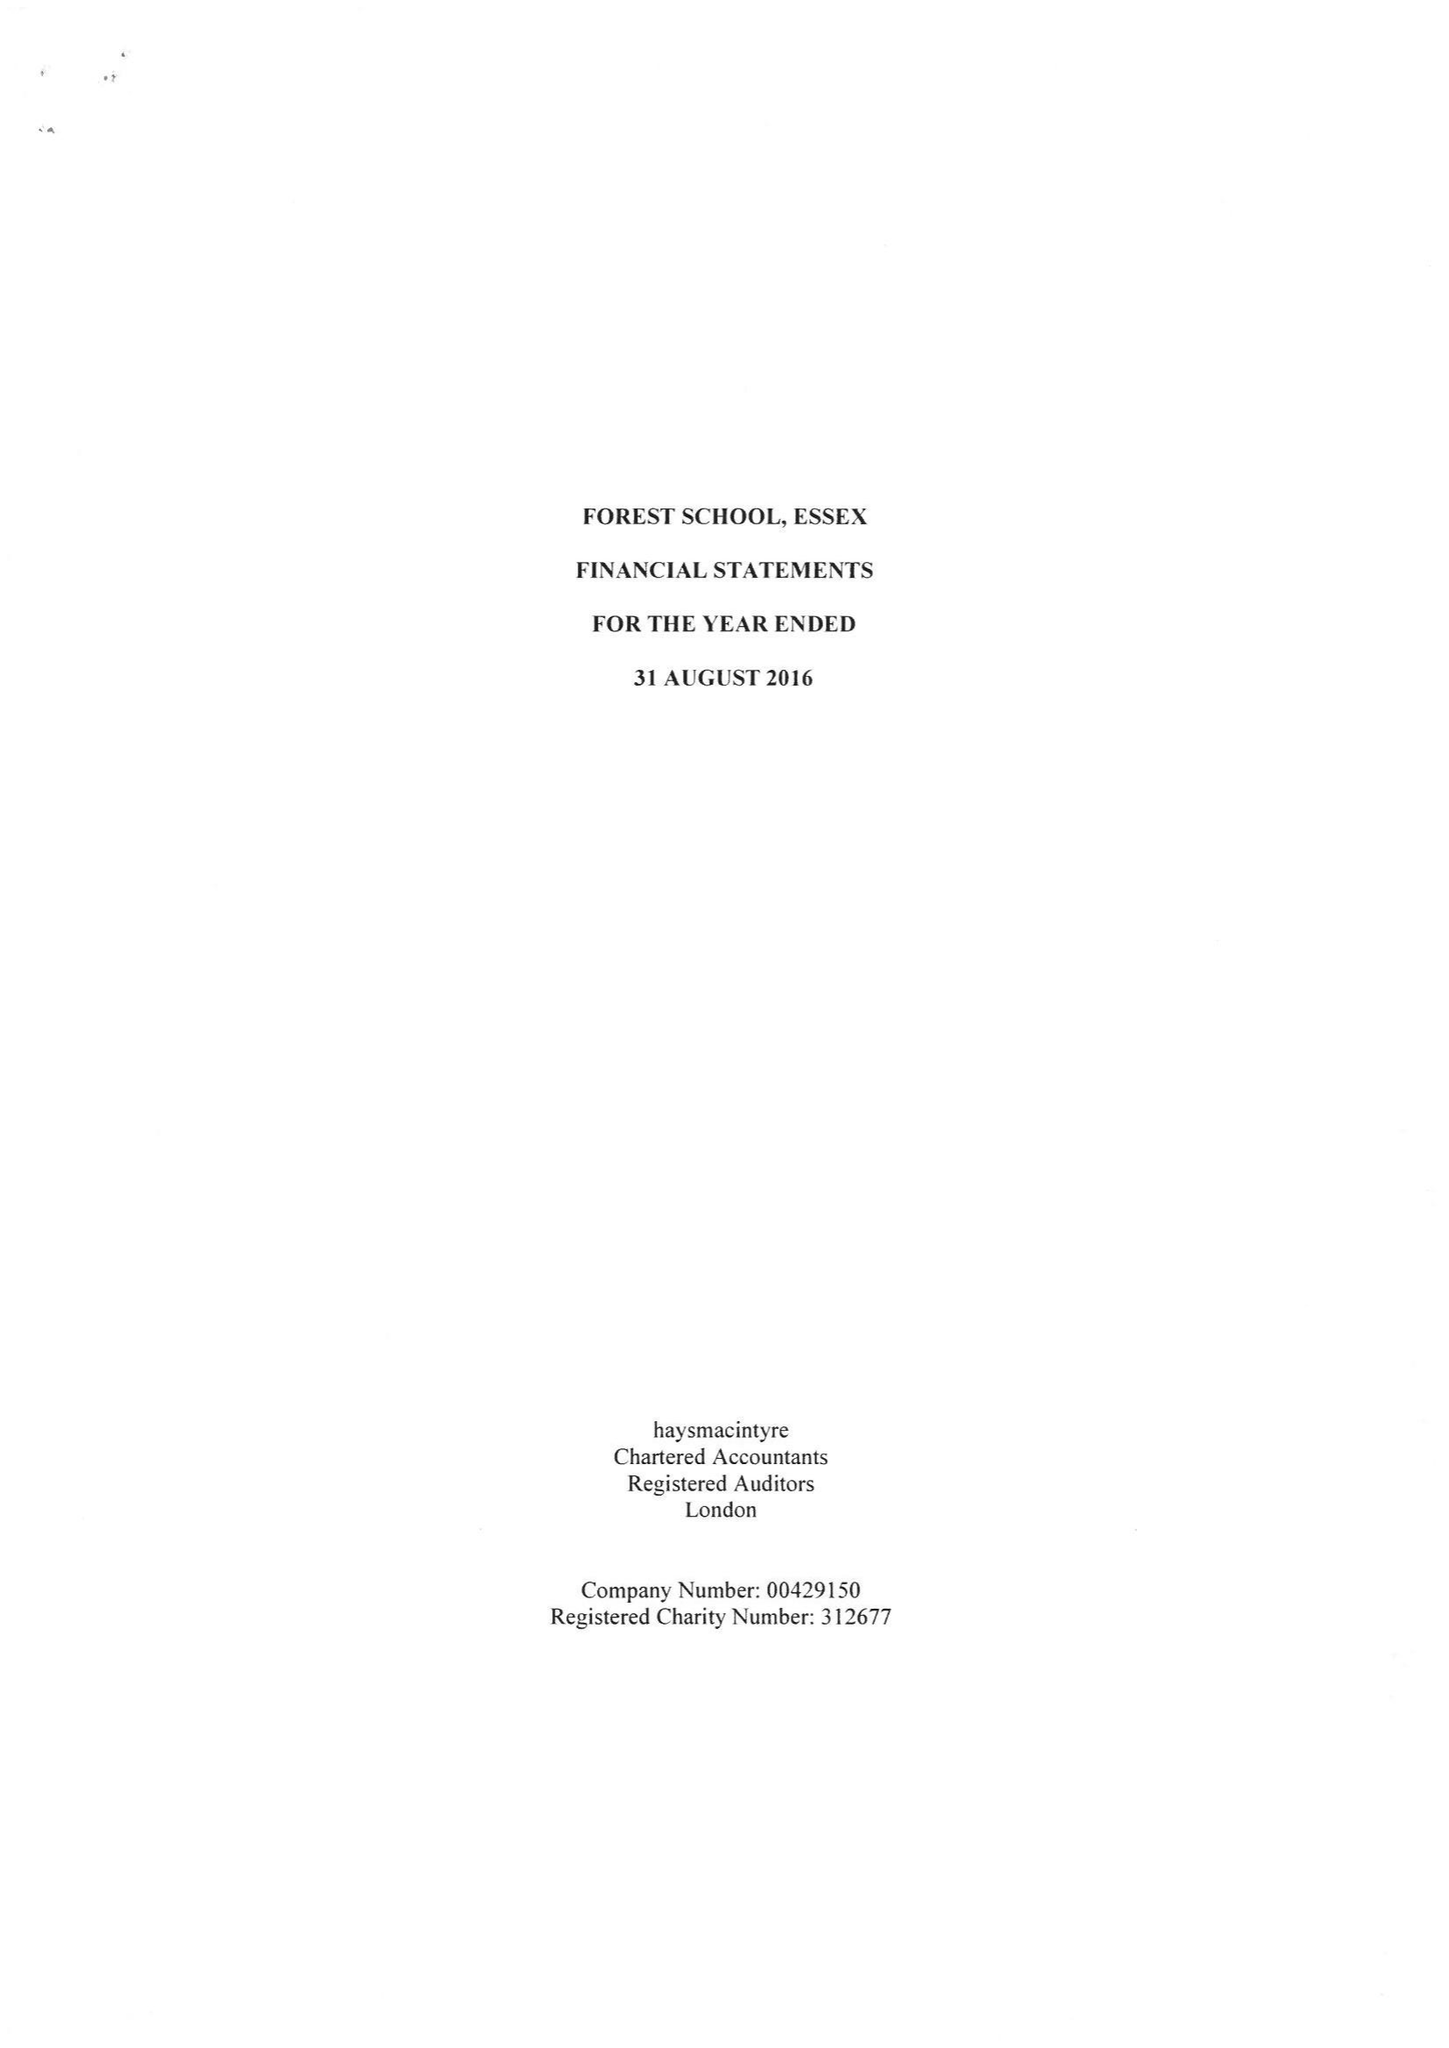What is the value for the spending_annually_in_british_pounds?
Answer the question using a single word or phrase. 20434510.00 